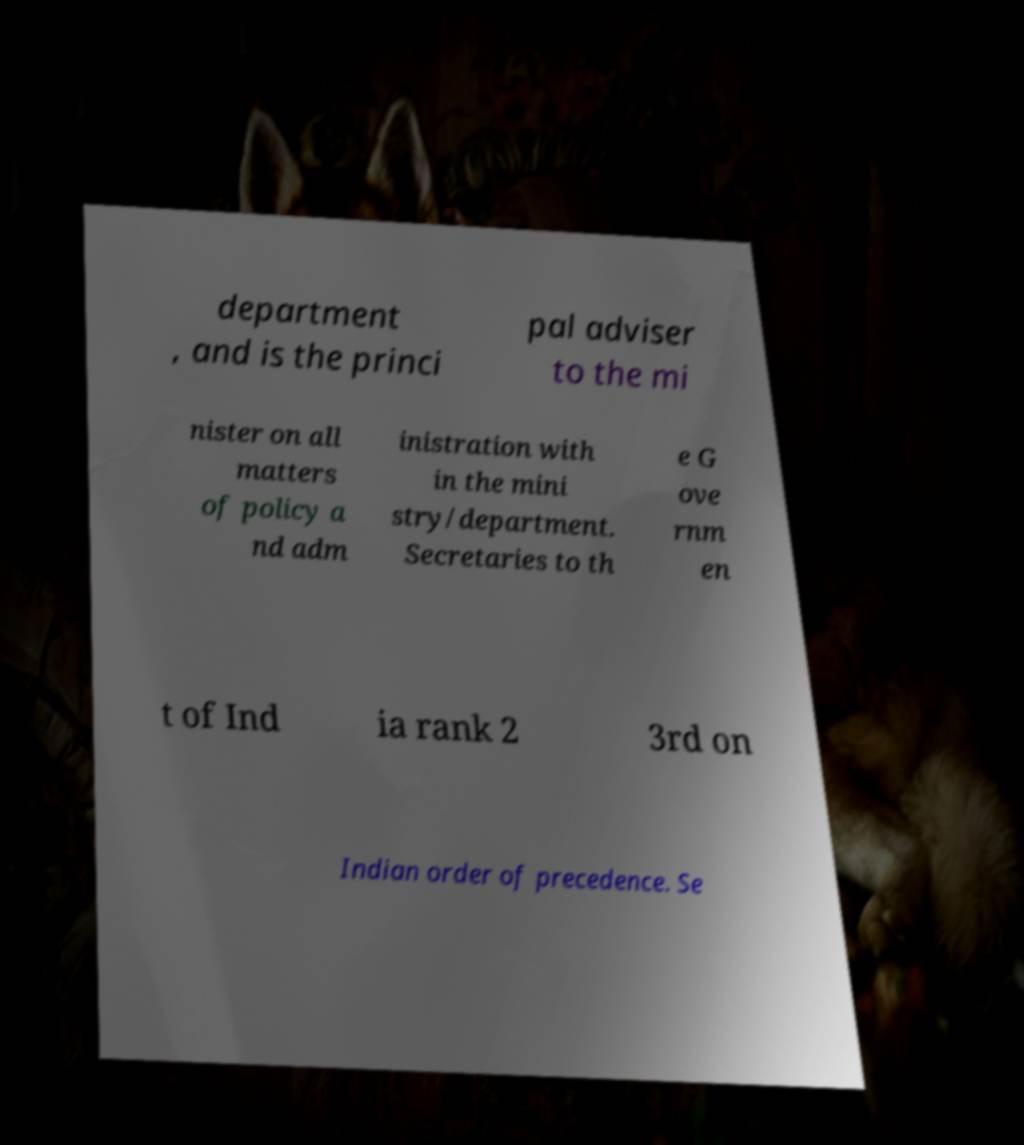Could you assist in decoding the text presented in this image and type it out clearly? department , and is the princi pal adviser to the mi nister on all matters of policy a nd adm inistration with in the mini stry/department. Secretaries to th e G ove rnm en t of Ind ia rank 2 3rd on Indian order of precedence. Se 